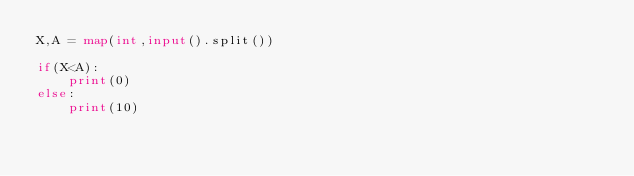<code> <loc_0><loc_0><loc_500><loc_500><_Python_>X,A = map(int,input().split())

if(X<A):
    print(0)
else:
    print(10)</code> 